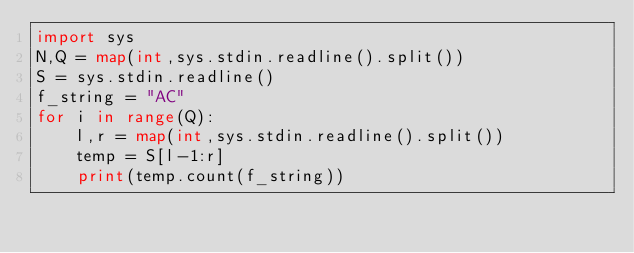<code> <loc_0><loc_0><loc_500><loc_500><_Python_>import sys
N,Q = map(int,sys.stdin.readline().split())
S = sys.stdin.readline()
f_string = "AC"
for i in range(Q):
    l,r = map(int,sys.stdin.readline().split())
    temp = S[l-1:r]
    print(temp.count(f_string))</code> 